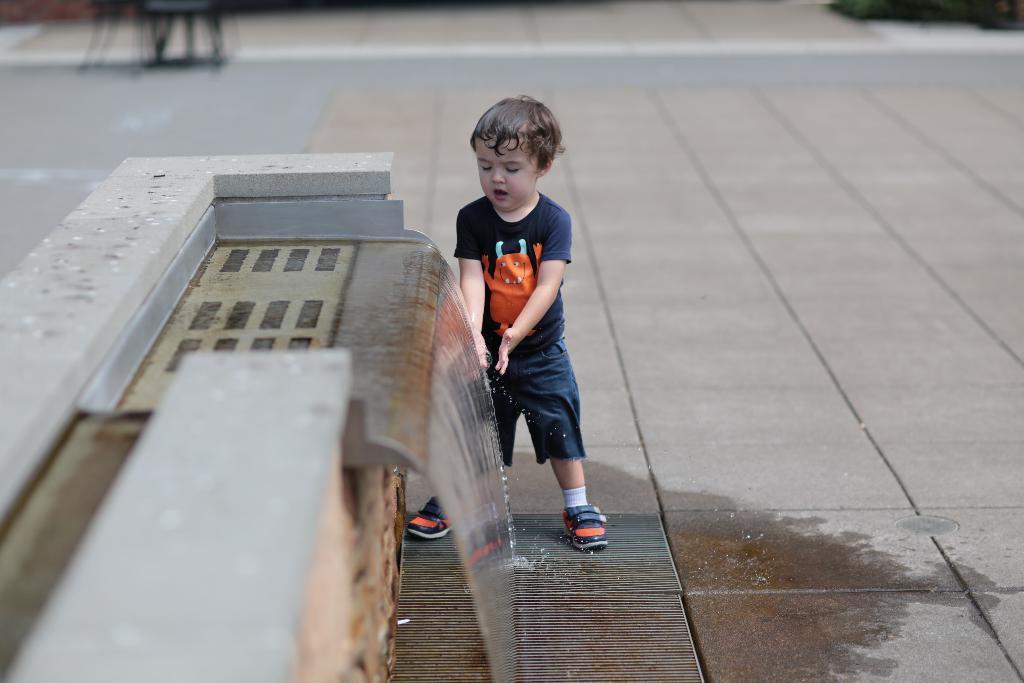Please provide a concise description of this image. In this image there is a boy standing near the artificial waterfall fountain, and there is a blur background. 